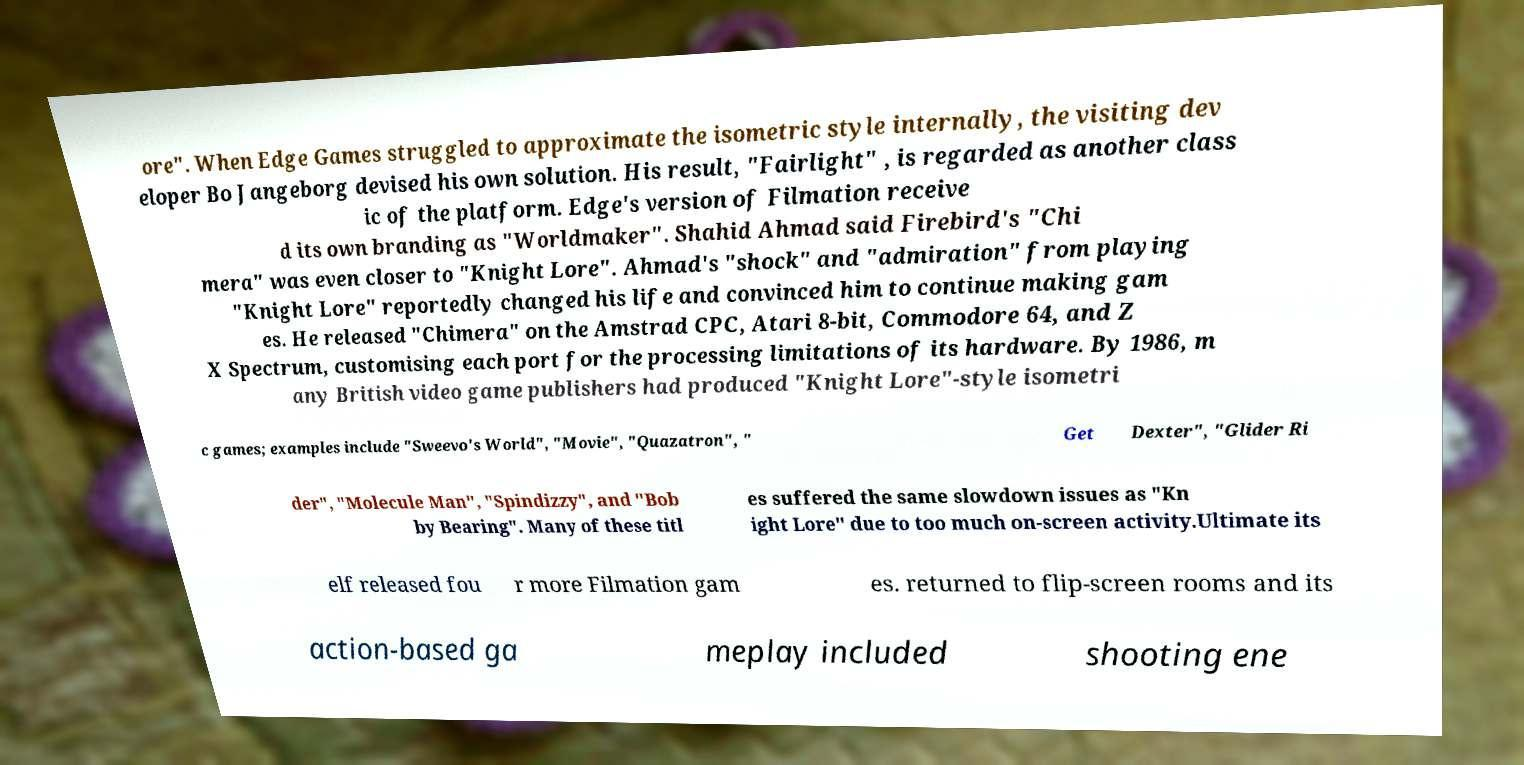Please identify and transcribe the text found in this image. ore". When Edge Games struggled to approximate the isometric style internally, the visiting dev eloper Bo Jangeborg devised his own solution. His result, "Fairlight" , is regarded as another class ic of the platform. Edge's version of Filmation receive d its own branding as "Worldmaker". Shahid Ahmad said Firebird's "Chi mera" was even closer to "Knight Lore". Ahmad's "shock" and "admiration" from playing "Knight Lore" reportedly changed his life and convinced him to continue making gam es. He released "Chimera" on the Amstrad CPC, Atari 8-bit, Commodore 64, and Z X Spectrum, customising each port for the processing limitations of its hardware. By 1986, m any British video game publishers had produced "Knight Lore"-style isometri c games; examples include "Sweevo's World", "Movie", "Quazatron", " Get Dexter", "Glider Ri der", "Molecule Man", "Spindizzy", and "Bob by Bearing". Many of these titl es suffered the same slowdown issues as "Kn ight Lore" due to too much on-screen activity.Ultimate its elf released fou r more Filmation gam es. returned to flip-screen rooms and its action-based ga meplay included shooting ene 